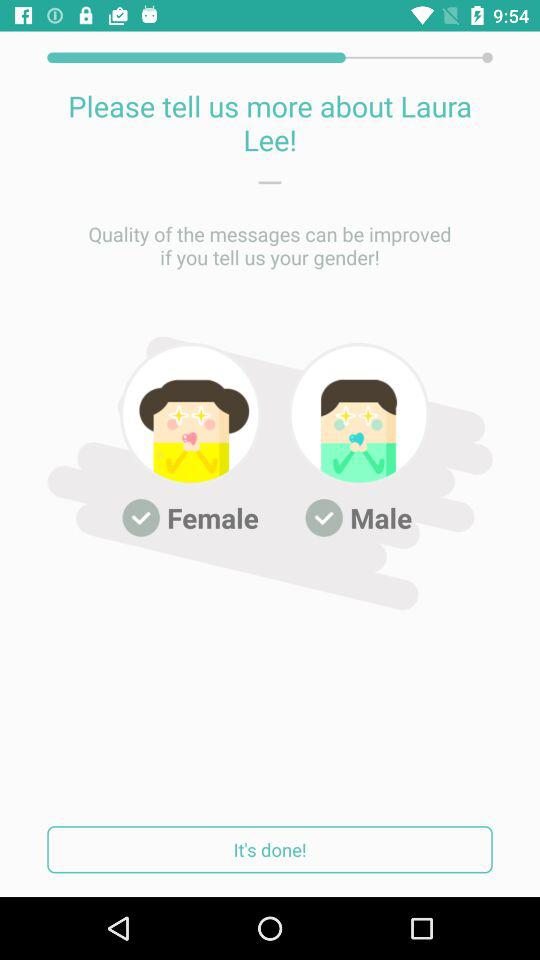What's the user name? The user name is Laura Lee. 